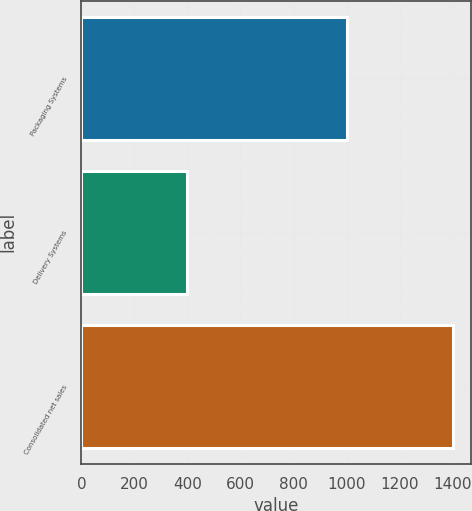Convert chart. <chart><loc_0><loc_0><loc_500><loc_500><bar_chart><fcel>Packaging Systems<fcel>Delivery Systems<fcel>Consolidated net sales<nl><fcel>1000.7<fcel>400.2<fcel>1399.8<nl></chart> 